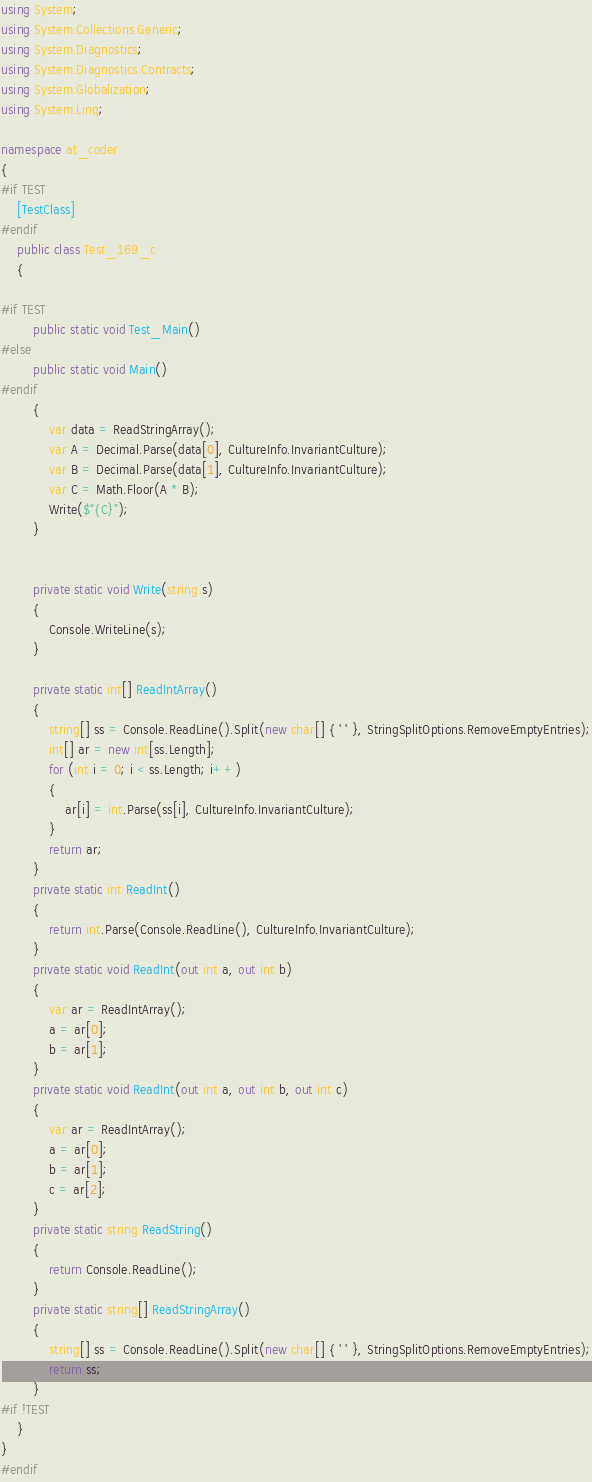Convert code to text. <code><loc_0><loc_0><loc_500><loc_500><_C#_>
using System;
using System.Collections.Generic;
using System.Diagnostics;
using System.Diagnostics.Contracts;
using System.Globalization;
using System.Linq;

namespace at_coder
{
#if TEST
    [TestClass]
#endif
    public class Test_169_c
    {

#if TEST
        public static void Test_Main()
#else
        public static void Main()
#endif
        {
            var data = ReadStringArray();
            var A = Decimal.Parse(data[0], CultureInfo.InvariantCulture);
            var B = Decimal.Parse(data[1], CultureInfo.InvariantCulture);
            var C = Math.Floor(A * B);
            Write($"{C}");
        }


        private static void Write(string s)
        {
            Console.WriteLine(s);
        }

        private static int[] ReadIntArray()
        {
            string[] ss = Console.ReadLine().Split(new char[] { ' ' }, StringSplitOptions.RemoveEmptyEntries);
            int[] ar = new int[ss.Length];
            for (int i = 0; i < ss.Length; i++)
            {
                ar[i] = int.Parse(ss[i], CultureInfo.InvariantCulture);
            }
            return ar;
        }
        private static int ReadInt()
        {
            return int.Parse(Console.ReadLine(), CultureInfo.InvariantCulture);
        }
        private static void ReadInt(out int a, out int b)
        {
            var ar = ReadIntArray();
            a = ar[0];
            b = ar[1];
        }
        private static void ReadInt(out int a, out int b, out int c)
        {
            var ar = ReadIntArray();
            a = ar[0];
            b = ar[1];
            c = ar[2];
        }
        private static string ReadString()
        {
            return Console.ReadLine();
        }
        private static string[] ReadStringArray()
        {
            string[] ss = Console.ReadLine().Split(new char[] { ' ' }, StringSplitOptions.RemoveEmptyEntries);
            return ss;
        }
#if !TEST
    }
}
#endif
</code> 